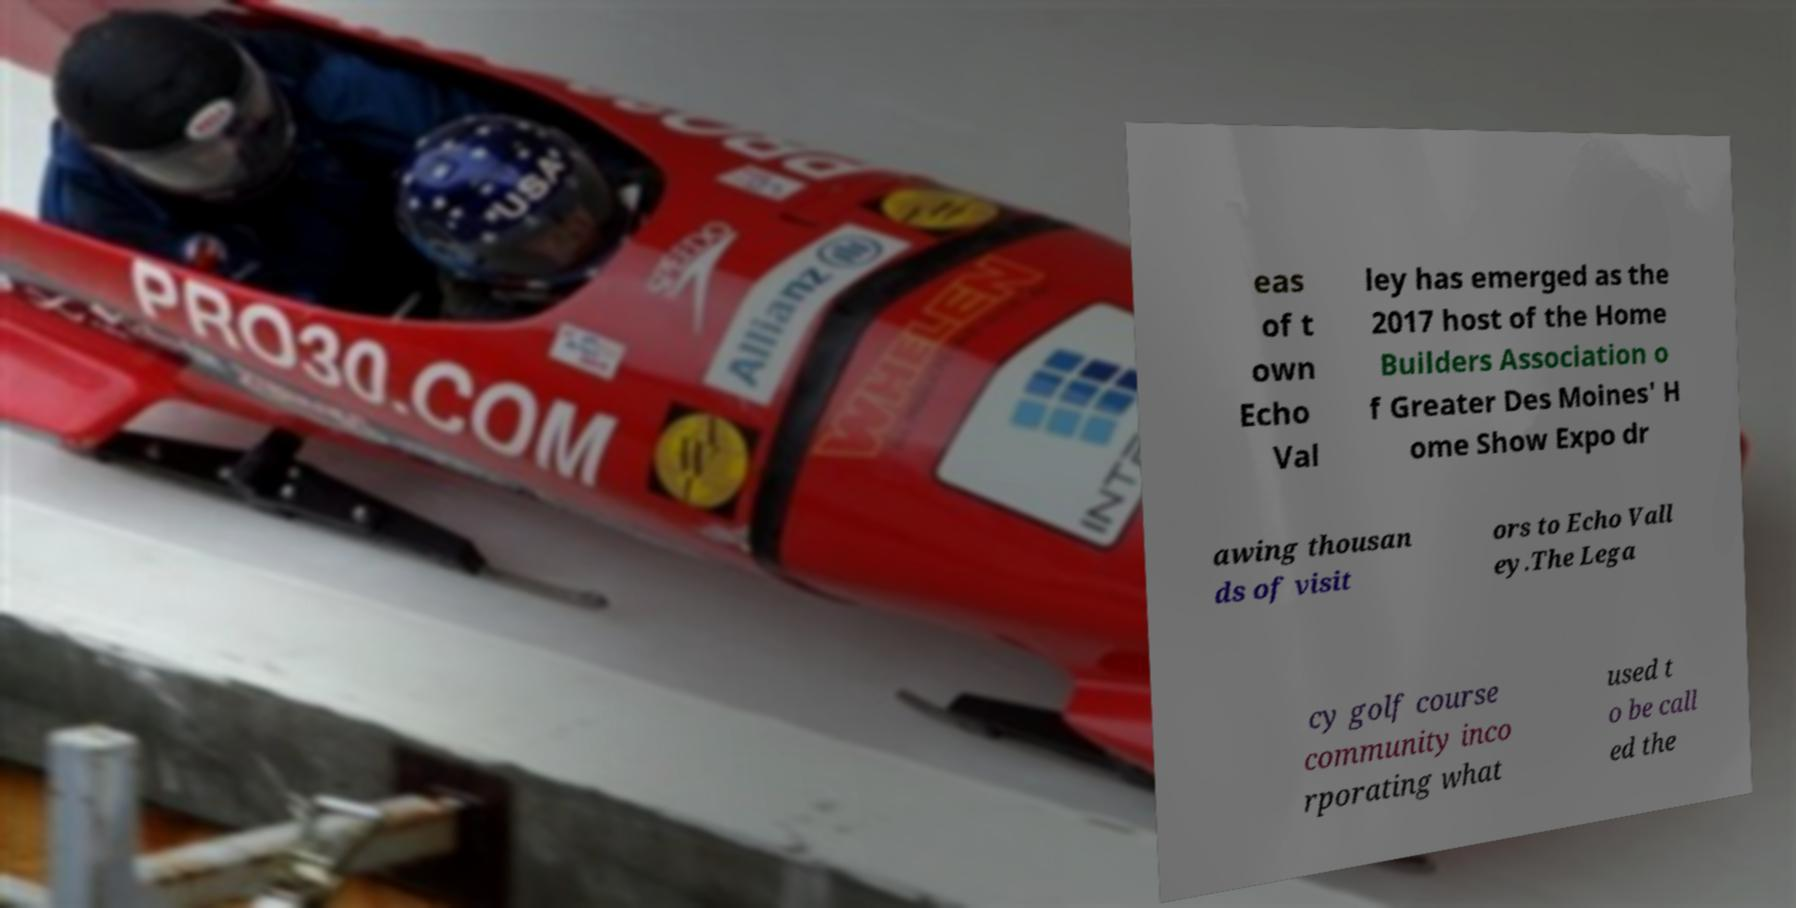Please identify and transcribe the text found in this image. eas of t own Echo Val ley has emerged as the 2017 host of the Home Builders Association o f Greater Des Moines' H ome Show Expo dr awing thousan ds of visit ors to Echo Vall ey.The Lega cy golf course community inco rporating what used t o be call ed the 